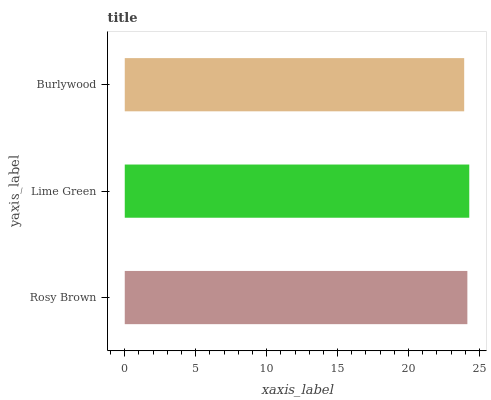Is Burlywood the minimum?
Answer yes or no. Yes. Is Lime Green the maximum?
Answer yes or no. Yes. Is Lime Green the minimum?
Answer yes or no. No. Is Burlywood the maximum?
Answer yes or no. No. Is Lime Green greater than Burlywood?
Answer yes or no. Yes. Is Burlywood less than Lime Green?
Answer yes or no. Yes. Is Burlywood greater than Lime Green?
Answer yes or no. No. Is Lime Green less than Burlywood?
Answer yes or no. No. Is Rosy Brown the high median?
Answer yes or no. Yes. Is Rosy Brown the low median?
Answer yes or no. Yes. Is Lime Green the high median?
Answer yes or no. No. Is Lime Green the low median?
Answer yes or no. No. 